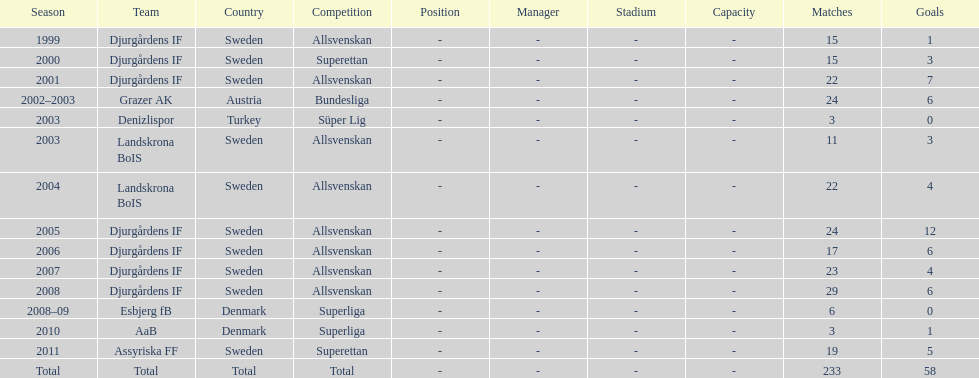What season has the most goals? 2005. 